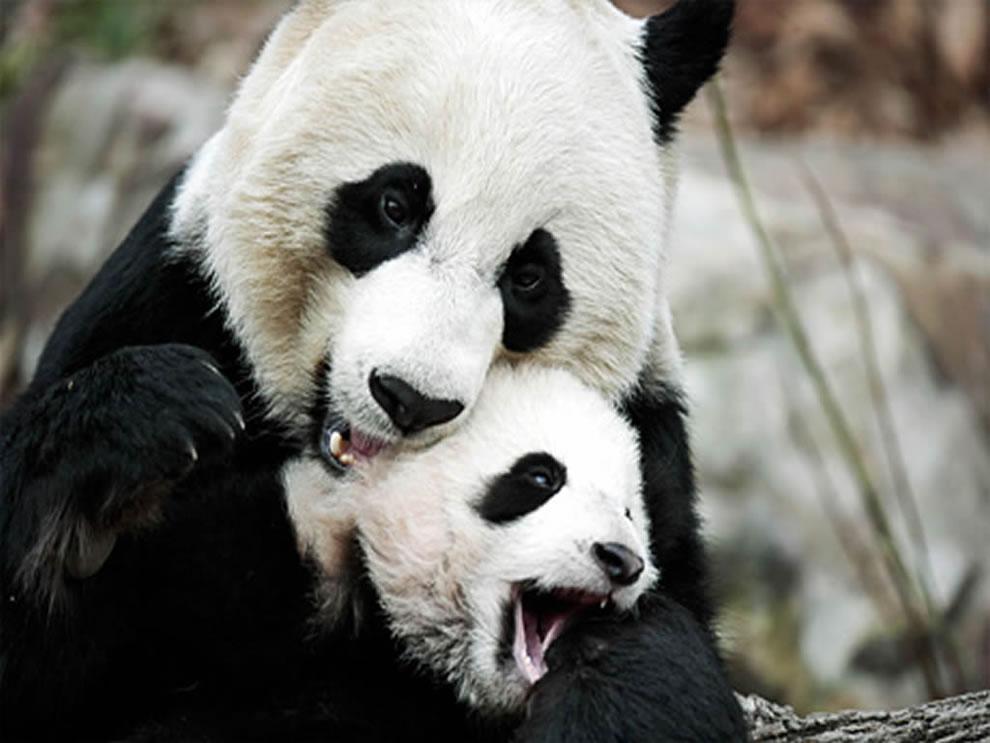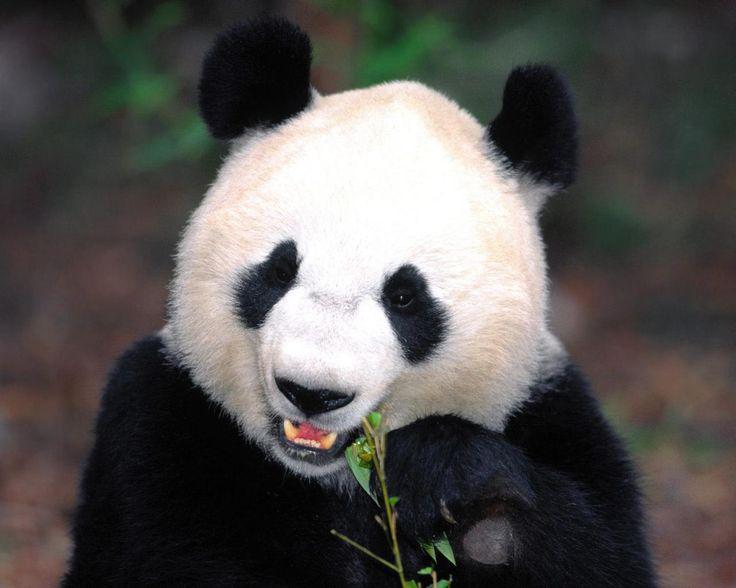The first image is the image on the left, the second image is the image on the right. For the images displayed, is the sentence "In one of the photos, a panda is eating a bamboo shoot" factually correct? Answer yes or no. Yes. The first image is the image on the left, the second image is the image on the right. For the images displayed, is the sentence "There are more panda bears in the left image than in the right." factually correct? Answer yes or no. Yes. 